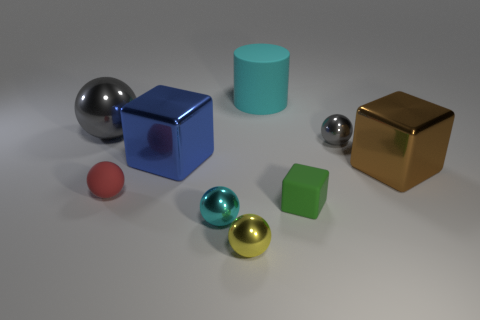Subtract all tiny metal spheres. How many spheres are left? 2 Subtract all green cubes. How many cubes are left? 2 Subtract all blue cubes. How many gray balls are left? 2 Subtract all cylinders. How many objects are left? 8 Add 7 big cyan objects. How many big cyan objects are left? 8 Add 4 green matte blocks. How many green matte blocks exist? 5 Subtract 1 brown cubes. How many objects are left? 8 Subtract all yellow blocks. Subtract all green cylinders. How many blocks are left? 3 Subtract all big rubber cylinders. Subtract all cyan rubber cylinders. How many objects are left? 7 